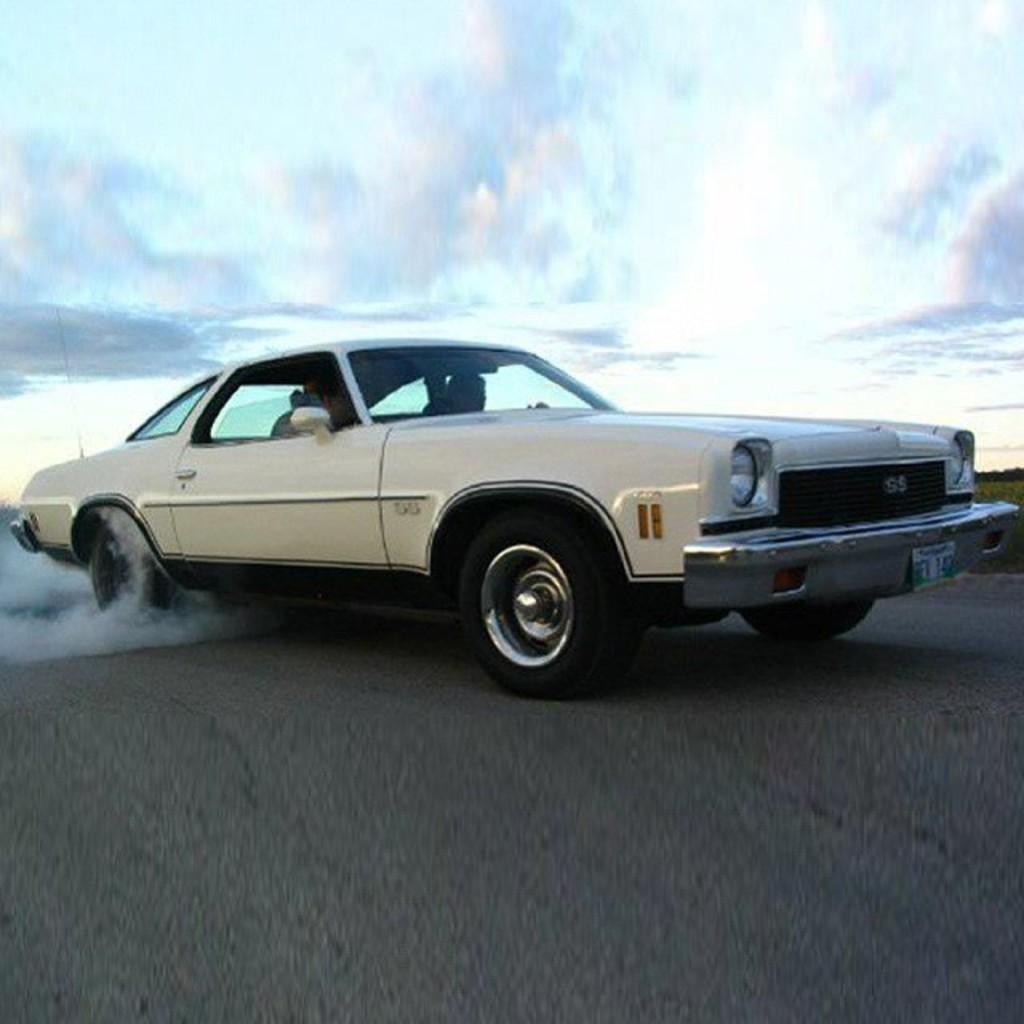What is the color of the car in the image? The car is white in color. What can be seen inside the car? There are people in the car. What is visible in the background of the image? There is smoke and the sky visible in the background. What type of beast is causing the smoke in the image? There is no beast present in the image, and the smoke is not attributed to any specific cause. 